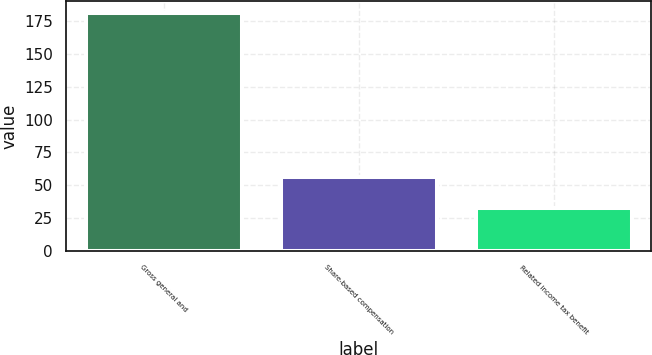Convert chart. <chart><loc_0><loc_0><loc_500><loc_500><bar_chart><fcel>Gross general and<fcel>Share-based compensation<fcel>Related income tax benefit<nl><fcel>181<fcel>56<fcel>33<nl></chart> 